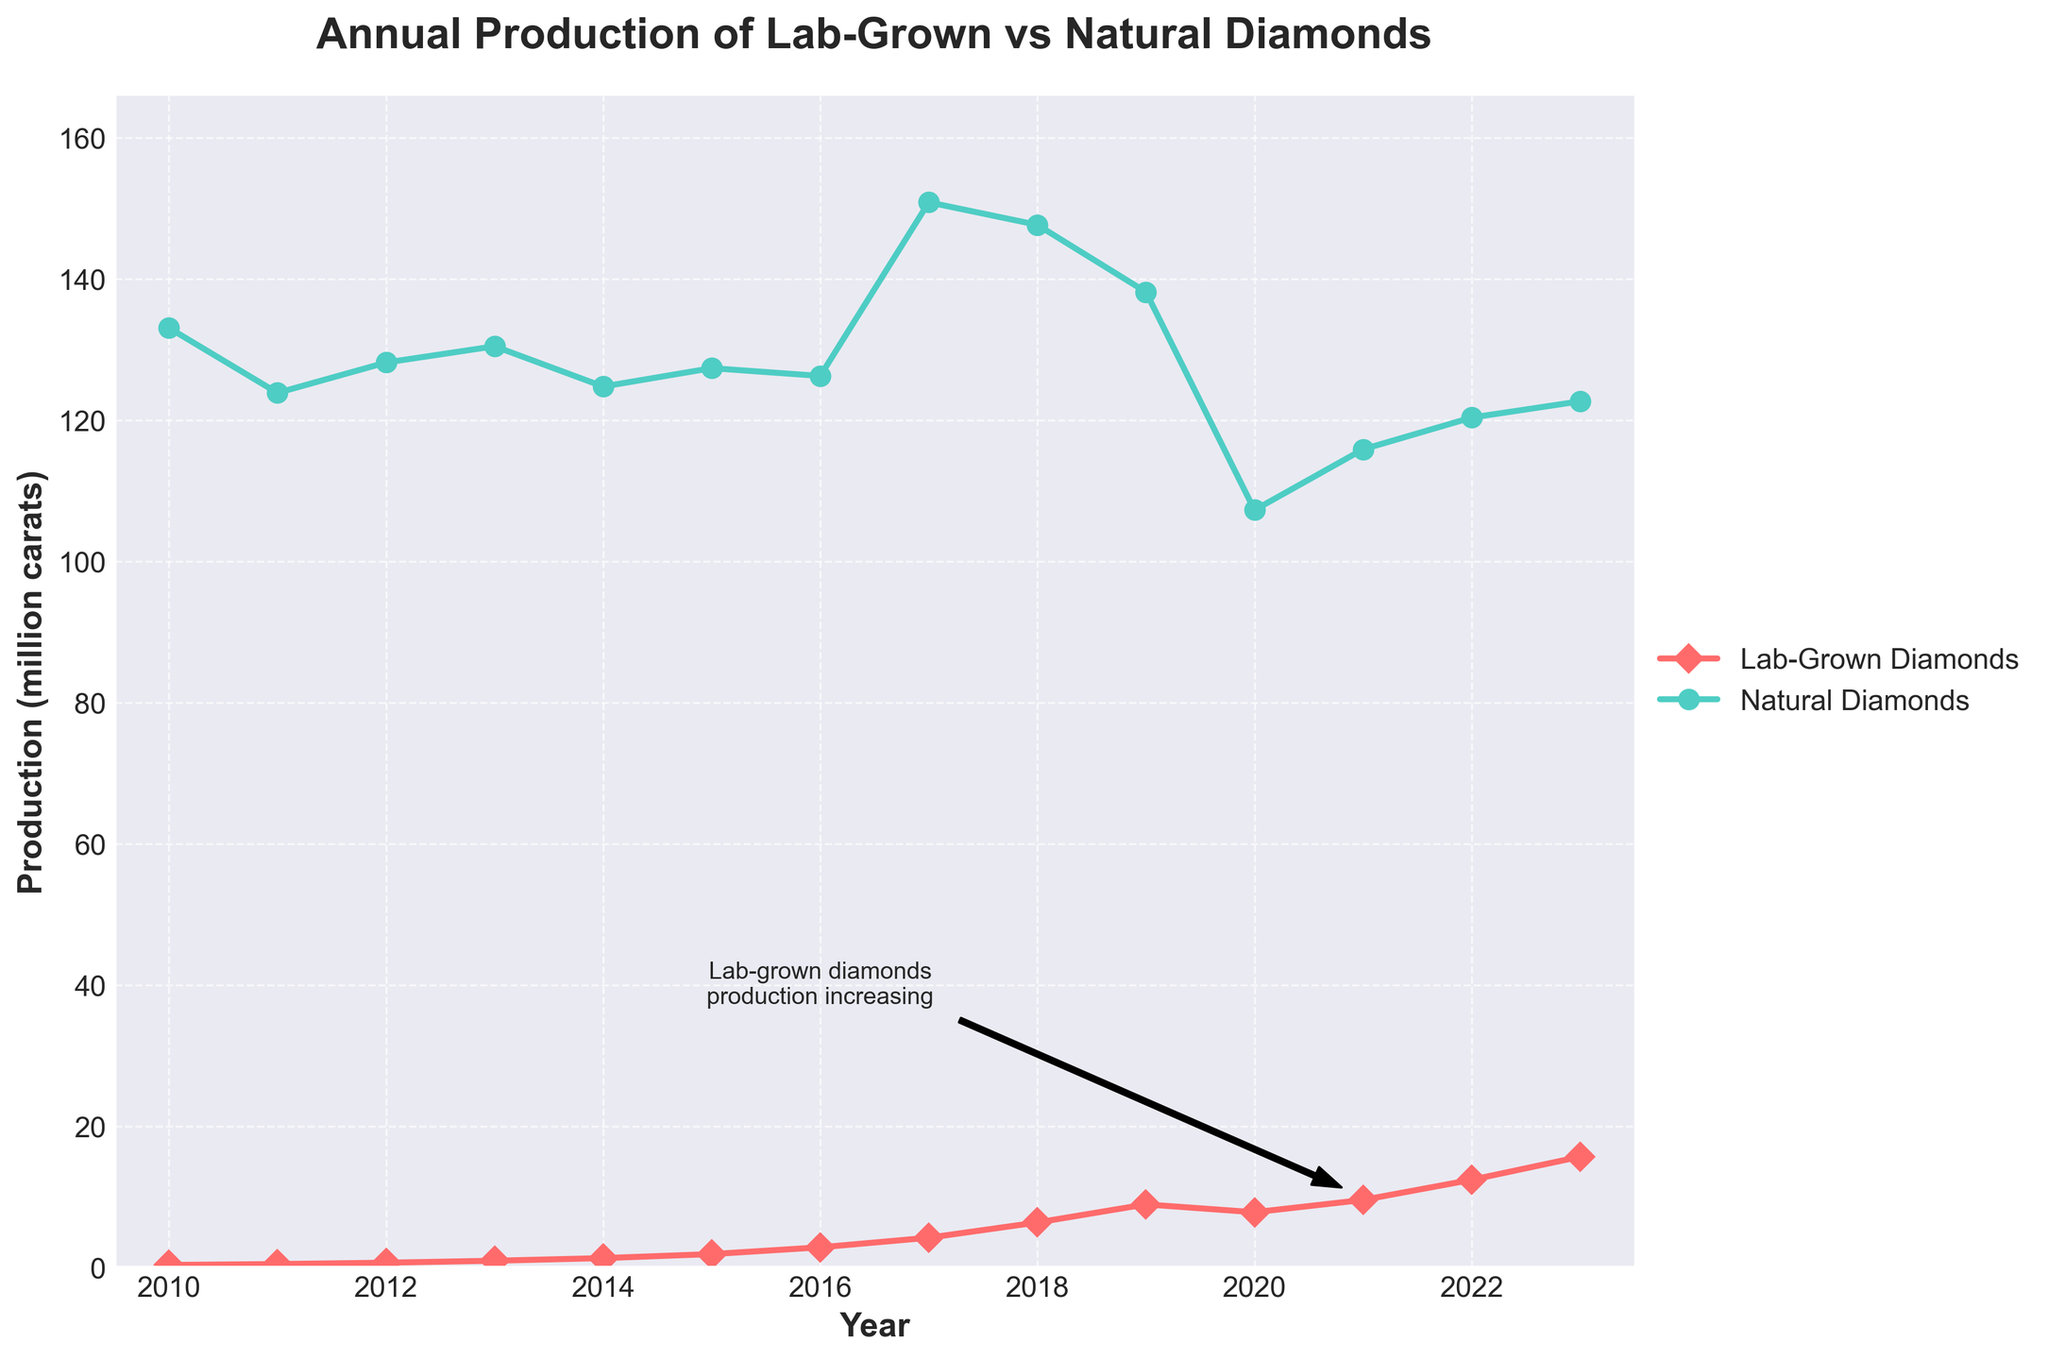What's the overall trend in the production of lab-grown diamonds from 2010 to 2023? The production of lab-grown diamonds shows a significant and steady increase from 0.35 million carats in 2010 to 15.68 million carats in 2023.
Answer: Steady increase What year did the production of lab-grown diamonds surpass 5 million carats? By looking at the line representing lab-grown diamonds, it surpasses 5 million carats between 2017 and 2018. Specifically, in 2018, the production reaches 6.37 million carats.
Answer: 2018 What is the difference between the highest and lowest production years for natural diamonds? The highest production year for natural diamonds is 2017 with 150.9 million carats, and the lowest is 2020 with 107.3 million carats. The difference is 150.9 - 107.3.
Answer: 43.6 million carats How did the production of natural diamonds change from 2010 to 2023? The production of natural diamonds fluctuated but generally decreased from 133.1 million carats in 2010 to 122.7 million carats in 2023.
Answer: Generally decreased In which year did lab-grown diamonds see the highest year-over-year growth? The year-over-year growth can be calculated by observing the steepest increase in the line for lab-grown diamonds. The steepest increase occurs between 2016 (2.85 million carats) and 2017 (4.21 million carats). The increase is 4.21 - 2.85.
Answer: 2017 Which type of diamond production was more affected by the year 2020, and how? In 2020, natural diamond production dropped significantly from 138.2 million carats in 2019 to 107.3 million carats in 2020. Lab-grown diamonds also decreased from 8.93 million carats in 2019 to 7.82 million carats in 2020, but not as drastically.
Answer: Natural diamonds, significant drop Which year experienced the highest production for natural diamonds? Looking at the top of the natural diamonds line, the highest point is in the year 2017, with 150.9 million carats.
Answer: 2017 Between which years did the production of lab-grown diamonds more than double? To see where the production of lab-grown diamonds more than doubles, we can compare the values for each span of years. Between 2015 (1.89 million carats) and 2017 (4.21 million carats), production more than doubled.
Answer: 2015 to 2017 What can we interpret from the annotation on the figure about lab-grown diamonds? The annotation points to a notable increase in lab-grown diamond production, explicitly highlighting that the trend is upward, especially around 2021.
Answer: Increasing production How does the production of natural diamonds in 2013 compare to that in 2023? The production of natural diamonds in 2013 was 130.5 million carats, while in 2023, it is 122.7 million carats. Comparing these values shows a decrease.
Answer: Decreased 